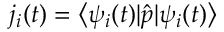<formula> <loc_0><loc_0><loc_500><loc_500>j _ { i } ( t ) = \left \langle \psi _ { i } ( t ) | \hat { p } | \psi _ { i } ( t ) \right \rangle</formula> 